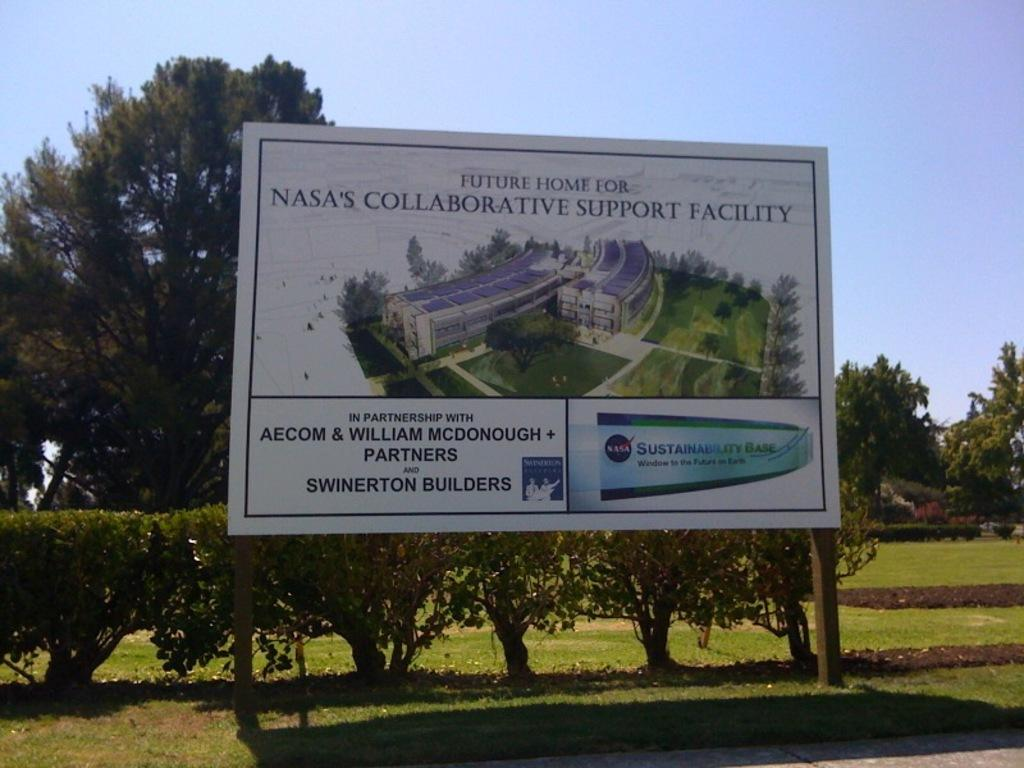Provide a one-sentence caption for the provided image. A billboard announces plans for a future NASA building. 